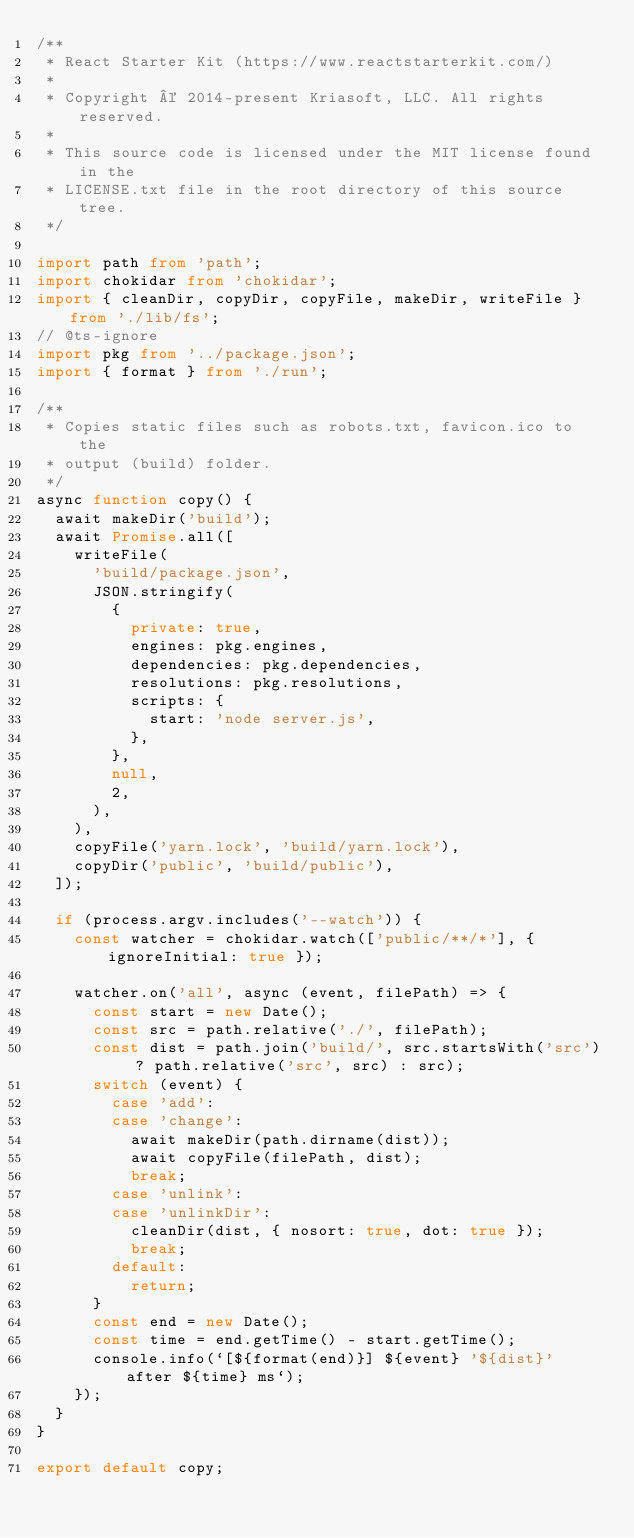<code> <loc_0><loc_0><loc_500><loc_500><_TypeScript_>/**
 * React Starter Kit (https://www.reactstarterkit.com/)
 *
 * Copyright © 2014-present Kriasoft, LLC. All rights reserved.
 *
 * This source code is licensed under the MIT license found in the
 * LICENSE.txt file in the root directory of this source tree.
 */

import path from 'path';
import chokidar from 'chokidar';
import { cleanDir, copyDir, copyFile, makeDir, writeFile } from './lib/fs';
// @ts-ignore
import pkg from '../package.json';
import { format } from './run';

/**
 * Copies static files such as robots.txt, favicon.ico to the
 * output (build) folder.
 */
async function copy() {
  await makeDir('build');
  await Promise.all([
    writeFile(
      'build/package.json',
      JSON.stringify(
        {
          private: true,
          engines: pkg.engines,
          dependencies: pkg.dependencies,
          resolutions: pkg.resolutions,
          scripts: {
            start: 'node server.js',
          },
        },
        null,
        2,
      ),
    ),
    copyFile('yarn.lock', 'build/yarn.lock'),
    copyDir('public', 'build/public'),
  ]);

  if (process.argv.includes('--watch')) {
    const watcher = chokidar.watch(['public/**/*'], { ignoreInitial: true });

    watcher.on('all', async (event, filePath) => {
      const start = new Date();
      const src = path.relative('./', filePath);
      const dist = path.join('build/', src.startsWith('src') ? path.relative('src', src) : src);
      switch (event) {
        case 'add':
        case 'change':
          await makeDir(path.dirname(dist));
          await copyFile(filePath, dist);
          break;
        case 'unlink':
        case 'unlinkDir':
          cleanDir(dist, { nosort: true, dot: true });
          break;
        default:
          return;
      }
      const end = new Date();
      const time = end.getTime() - start.getTime();
      console.info(`[${format(end)}] ${event} '${dist}' after ${time} ms`);
    });
  }
}

export default copy;
</code> 